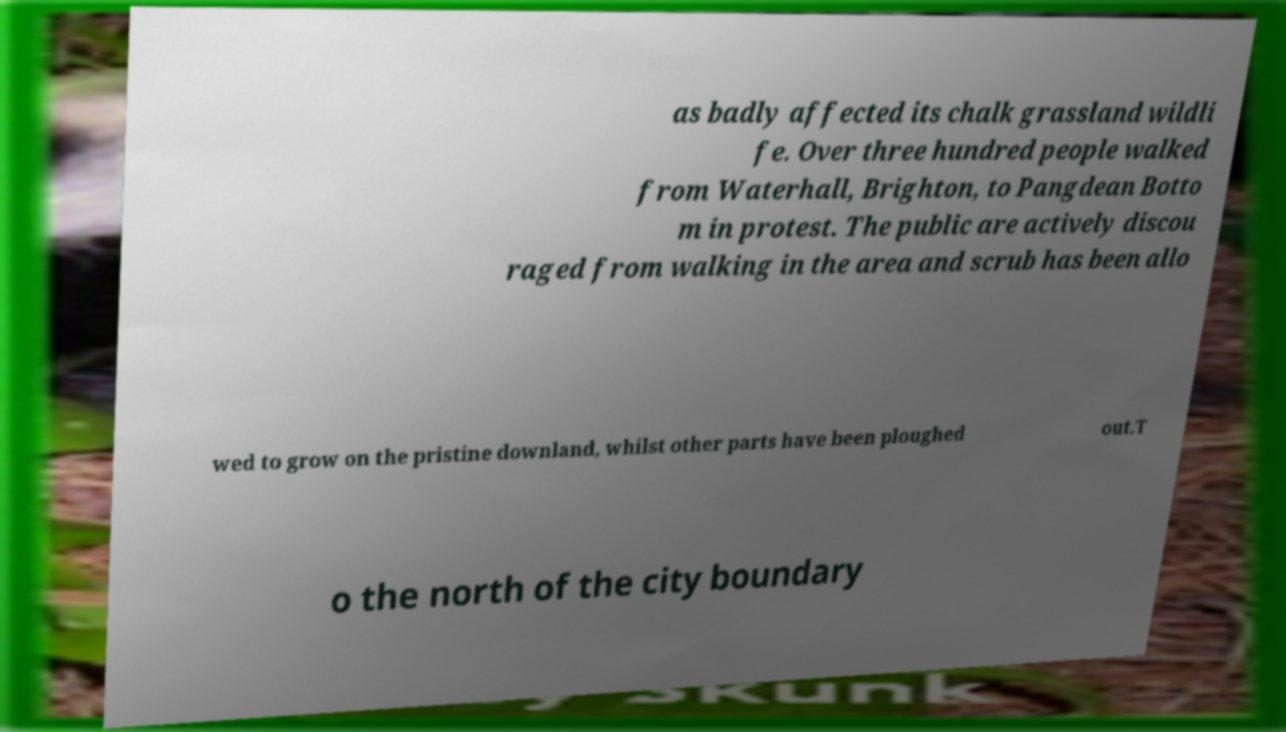For documentation purposes, I need the text within this image transcribed. Could you provide that? as badly affected its chalk grassland wildli fe. Over three hundred people walked from Waterhall, Brighton, to Pangdean Botto m in protest. The public are actively discou raged from walking in the area and scrub has been allo wed to grow on the pristine downland, whilst other parts have been ploughed out.T o the north of the city boundary 